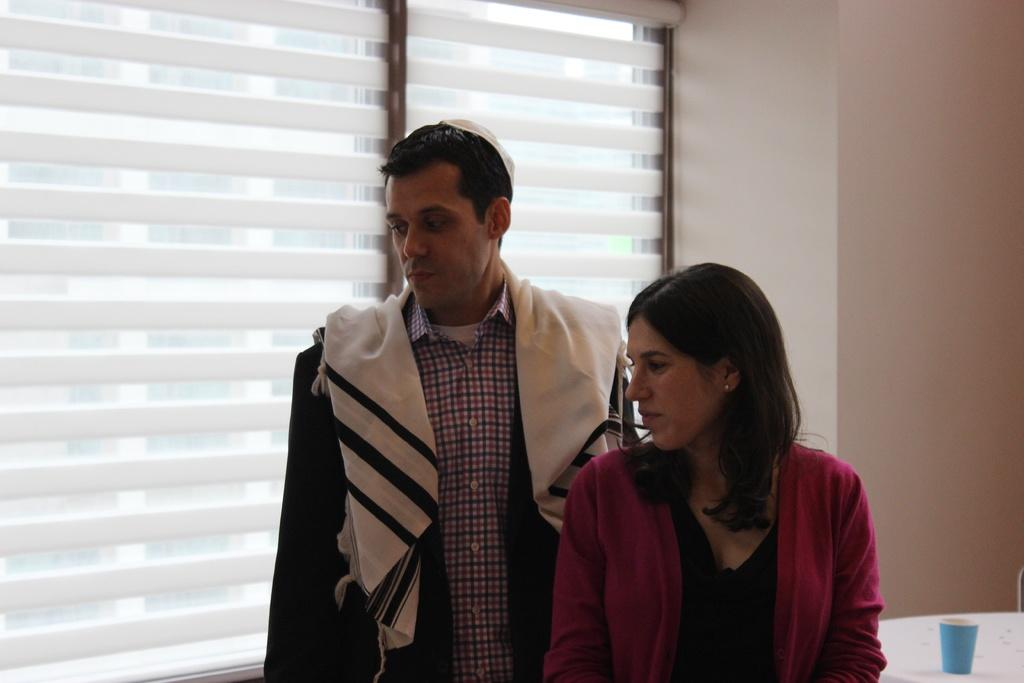How many people are present in the image? There is a man and a woman in the image. What is the man wearing on his shoulders? The man has a cloth on his shoulders. What can be seen in the background of the image? There is a window and a wall in the background of the image. Can you describe an object on a table in the background? There is a cup on a table in the background of the image. What type of tooth is visible in the image? There is no tooth present in the image. Is the scene taking place during winter in the image? The image does not provide any information about the season, so it cannot be determined if it is winter. 